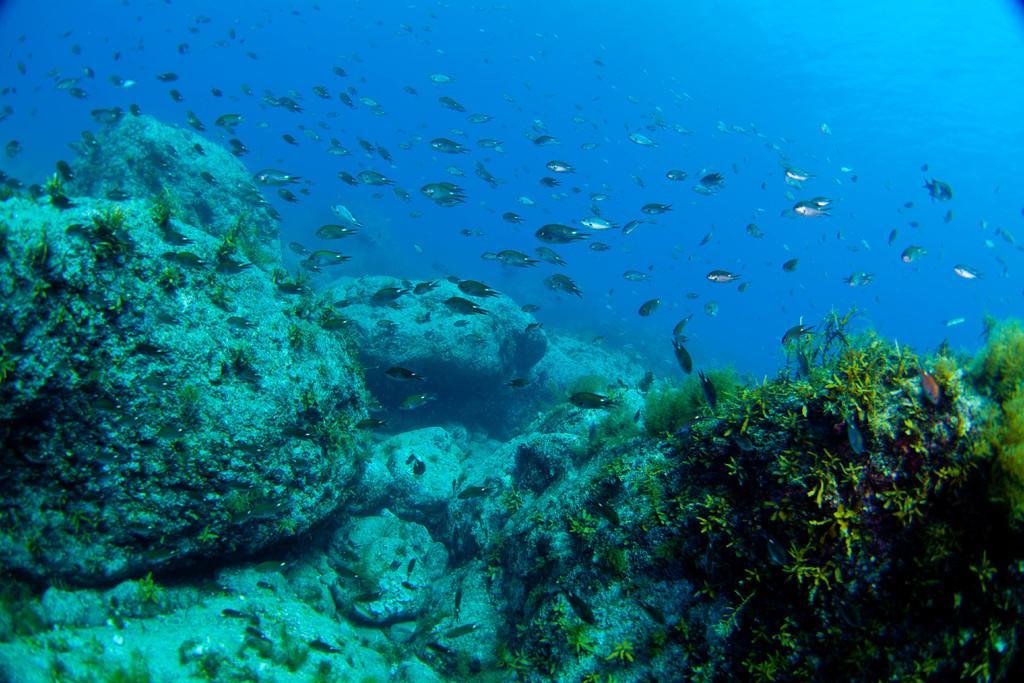In one or two sentences, can you explain what this image depicts? In this image we can see few fishes in the water and also we can see some rocks and the grass. 